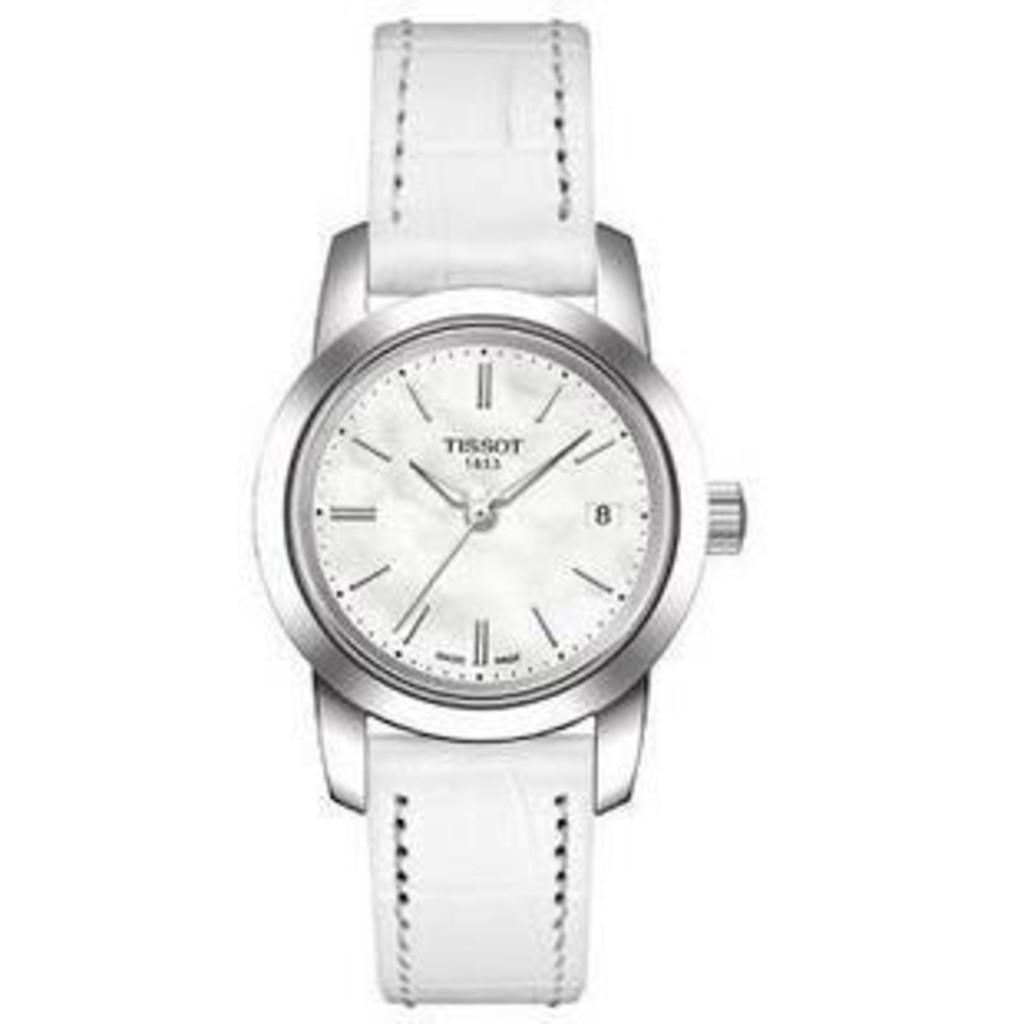<image>
Present a compact description of the photo's key features. A white Tisson wrist watch is displayed on a white back ground. 